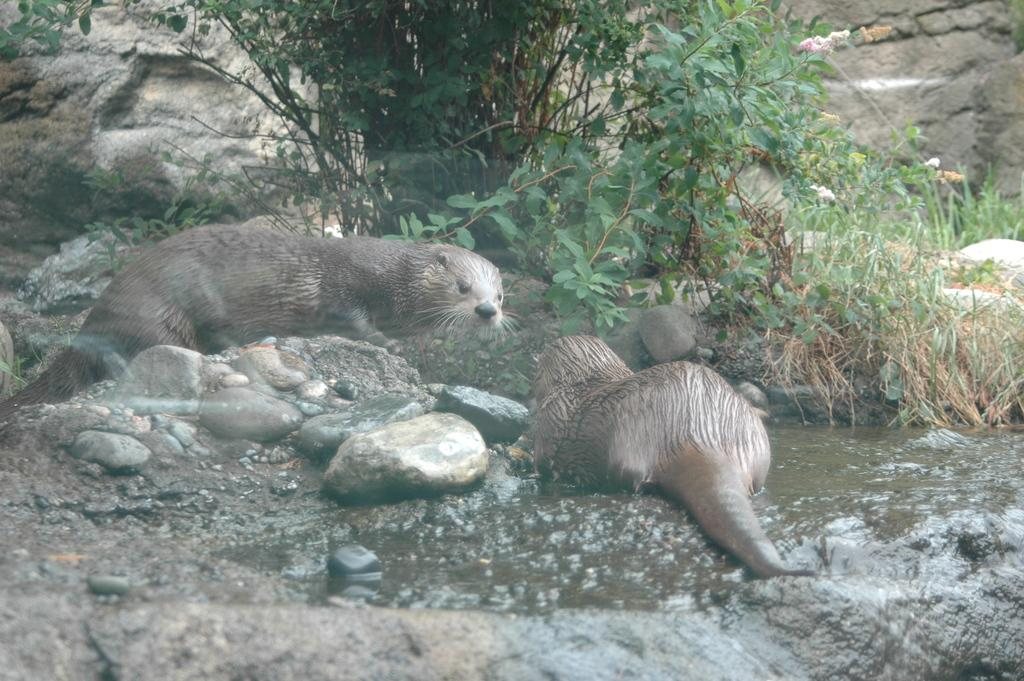Where was the image taken? The image was clicked outside. What can be seen at the top of the image? There are plants at the top of the image. What can be seen in the middle of the image? There are plants and animals in the middle of the image. What type of shop can be seen in the image? There is no shop present in the image. How many ants are visible on the plants in the image? There are no ants visible in the image; only plants and animals are present. 